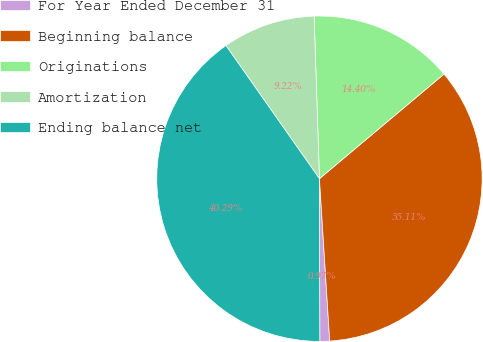<chart> <loc_0><loc_0><loc_500><loc_500><pie_chart><fcel>For Year Ended December 31<fcel>Beginning balance<fcel>Originations<fcel>Amortization<fcel>Ending balance net<nl><fcel>0.97%<fcel>35.11%<fcel>14.4%<fcel>9.22%<fcel>40.29%<nl></chart> 